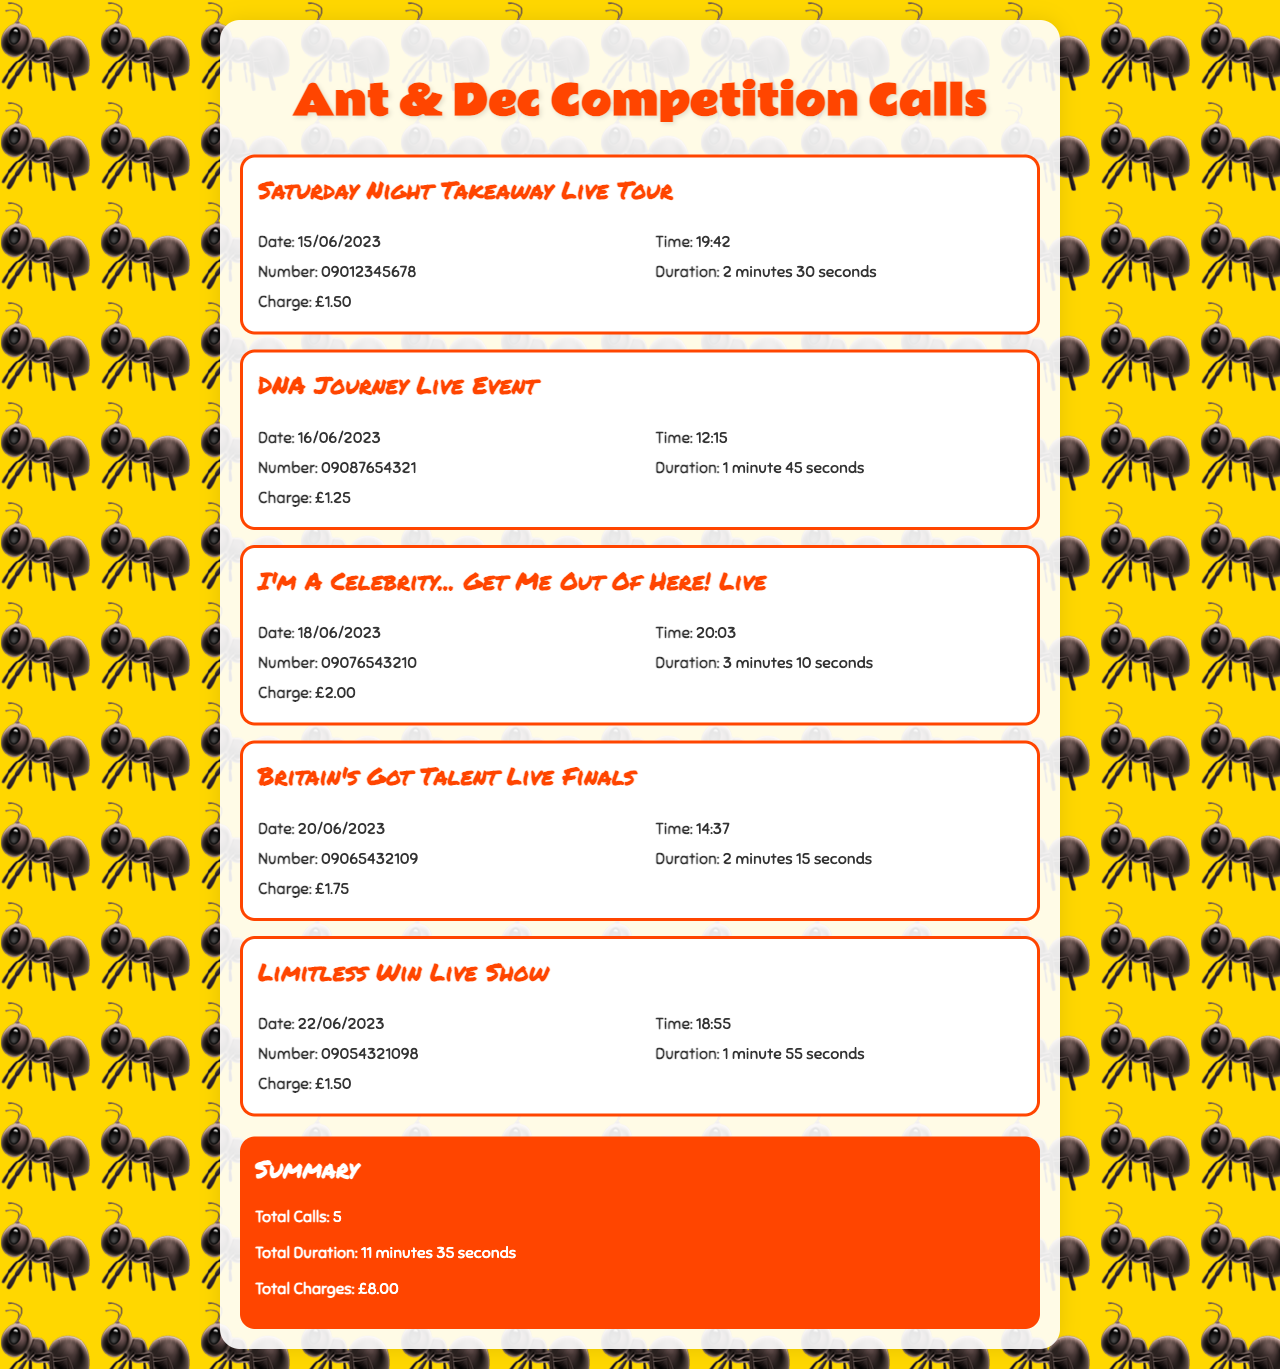What is the date of the first call? The first call is listed under "Saturday Night Takeaway Live Tour" which occurred on 15/06/2023.
Answer: 15/06/2023 What is the charge for the "DNA Journey Live Event"? The charge listed for the "DNA Journey Live Event" is £1.25.
Answer: £1.25 What was the longest call duration? The longest call duration is for "I'm A Celebrity... Get Me Out Of Here! Live," which lasted 3 minutes 10 seconds.
Answer: 3 minutes 10 seconds How many calls were made in total? The total number of calls is stated in the summary as 5.
Answer: 5 What is the total charge for all calls? The total charge for all calls is given in the summary as £8.00.
Answer: £8.00 What time was the "Limitless Win Live Show" call made? The call for "Limitless Win Live Show" was made at 18:55 on 22/06/2023.
Answer: 18:55 What number was called for "Britain's Got Talent Live Finals"? The number called for "Britain's Got Talent Live Finals" is 09065432109.
Answer: 09065432109 How many minutes were spent on calls altogether? The total duration of all calls is summarized as 11 minutes 35 seconds.
Answer: 11 minutes 35 seconds What event was called on 20/06/2023? The event called on 20/06/2023 is the "Britain's Got Talent Live Finals."
Answer: Britain's Got Talent Live Finals 